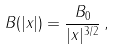Convert formula to latex. <formula><loc_0><loc_0><loc_500><loc_500>B ( | x | ) = \frac { B _ { 0 } } { | x | ^ { 3 / 2 } } \, ,</formula> 